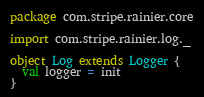Convert code to text. <code><loc_0><loc_0><loc_500><loc_500><_Scala_>package com.stripe.rainier.core

import com.stripe.rainier.log._

object Log extends Logger {
  val logger = init
}
</code> 